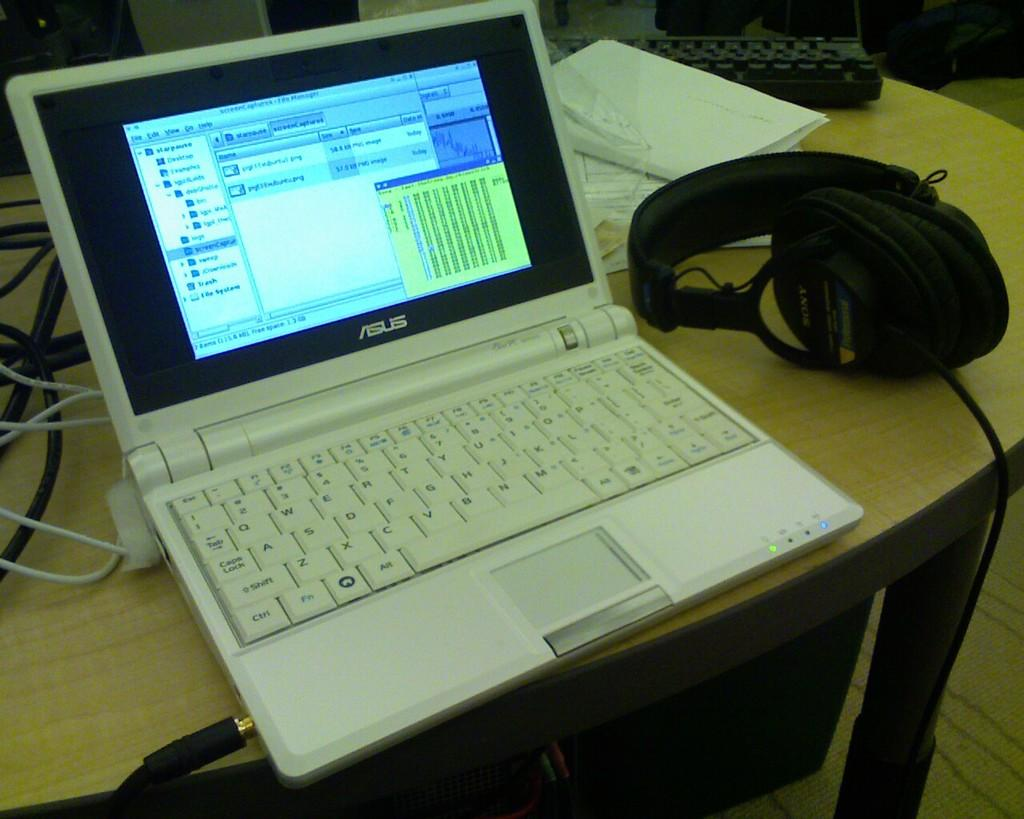<image>
Share a concise interpretation of the image provided. The white laptop sitting on the table is made by Asus. 